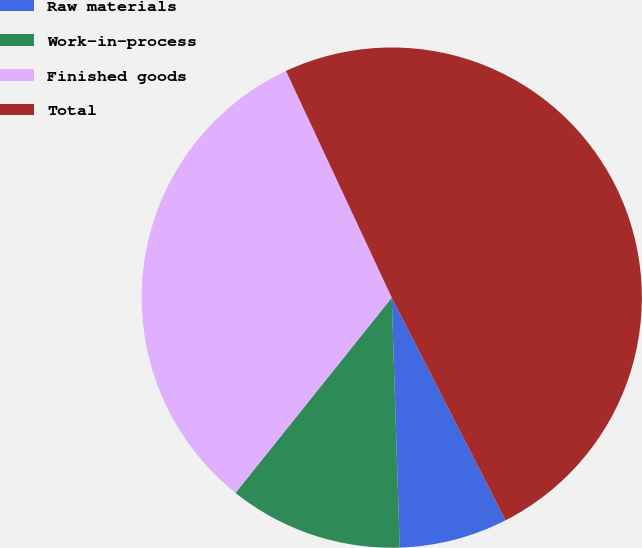Convert chart to OTSL. <chart><loc_0><loc_0><loc_500><loc_500><pie_chart><fcel>Raw materials<fcel>Work-in-process<fcel>Finished goods<fcel>Total<nl><fcel>7.01%<fcel>11.25%<fcel>32.31%<fcel>49.43%<nl></chart> 